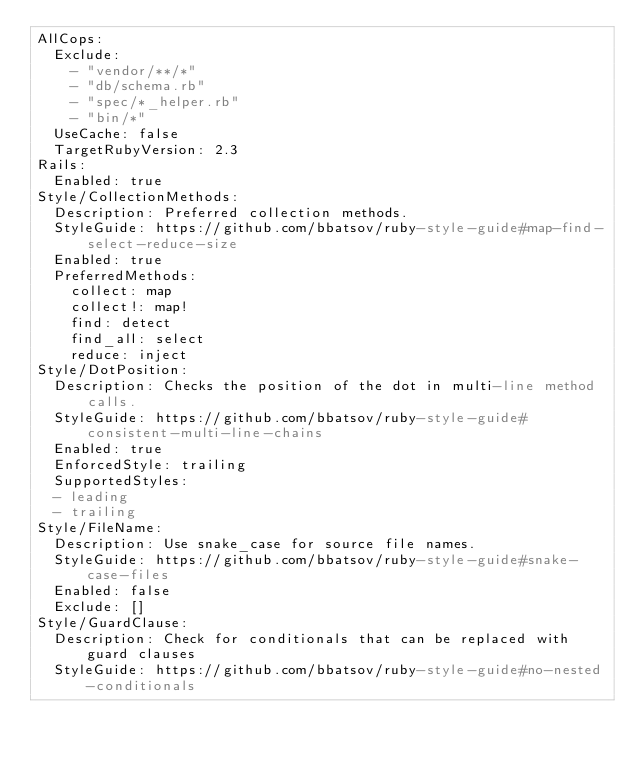Convert code to text. <code><loc_0><loc_0><loc_500><loc_500><_YAML_>AllCops:
  Exclude:
    - "vendor/**/*"
    - "db/schema.rb"
    - "spec/*_helper.rb"
    - "bin/*"
  UseCache: false
  TargetRubyVersion: 2.3
Rails:
  Enabled: true
Style/CollectionMethods:
  Description: Preferred collection methods.
  StyleGuide: https://github.com/bbatsov/ruby-style-guide#map-find-select-reduce-size
  Enabled: true
  PreferredMethods:
    collect: map
    collect!: map!
    find: detect
    find_all: select
    reduce: inject
Style/DotPosition:
  Description: Checks the position of the dot in multi-line method calls.
  StyleGuide: https://github.com/bbatsov/ruby-style-guide#consistent-multi-line-chains
  Enabled: true
  EnforcedStyle: trailing
  SupportedStyles:
  - leading
  - trailing
Style/FileName:
  Description: Use snake_case for source file names.
  StyleGuide: https://github.com/bbatsov/ruby-style-guide#snake-case-files
  Enabled: false
  Exclude: []
Style/GuardClause:
  Description: Check for conditionals that can be replaced with guard clauses
  StyleGuide: https://github.com/bbatsov/ruby-style-guide#no-nested-conditionals</code> 